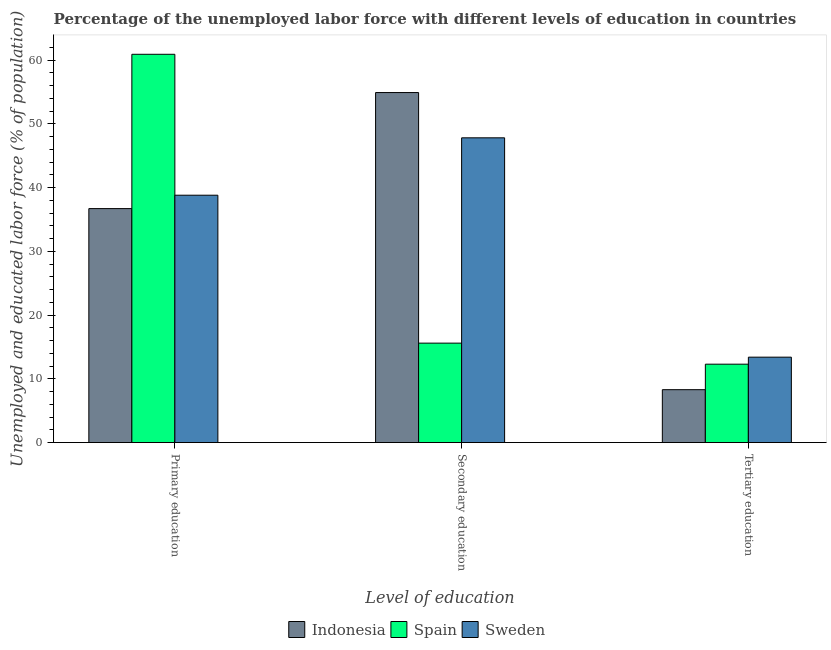How many different coloured bars are there?
Provide a short and direct response. 3. How many groups of bars are there?
Provide a succinct answer. 3. Are the number of bars on each tick of the X-axis equal?
Your answer should be very brief. Yes. What is the label of the 3rd group of bars from the left?
Keep it short and to the point. Tertiary education. What is the percentage of labor force who received tertiary education in Spain?
Ensure brevity in your answer.  12.3. Across all countries, what is the maximum percentage of labor force who received primary education?
Your answer should be very brief. 60.9. Across all countries, what is the minimum percentage of labor force who received primary education?
Keep it short and to the point. 36.7. In which country was the percentage of labor force who received tertiary education minimum?
Provide a succinct answer. Indonesia. What is the total percentage of labor force who received secondary education in the graph?
Keep it short and to the point. 118.3. What is the difference between the percentage of labor force who received primary education in Sweden and that in Spain?
Offer a very short reply. -22.1. What is the difference between the percentage of labor force who received tertiary education in Spain and the percentage of labor force who received primary education in Sweden?
Give a very brief answer. -26.5. What is the average percentage of labor force who received tertiary education per country?
Your answer should be compact. 11.33. What is the difference between the percentage of labor force who received tertiary education and percentage of labor force who received secondary education in Spain?
Your answer should be compact. -3.3. In how many countries, is the percentage of labor force who received primary education greater than 10 %?
Offer a terse response. 3. What is the ratio of the percentage of labor force who received primary education in Spain to that in Indonesia?
Provide a short and direct response. 1.66. Is the percentage of labor force who received primary education in Indonesia less than that in Spain?
Your answer should be compact. Yes. Is the difference between the percentage of labor force who received secondary education in Spain and Sweden greater than the difference between the percentage of labor force who received primary education in Spain and Sweden?
Your answer should be compact. No. What is the difference between the highest and the second highest percentage of labor force who received primary education?
Keep it short and to the point. 22.1. What is the difference between the highest and the lowest percentage of labor force who received primary education?
Give a very brief answer. 24.2. What does the 3rd bar from the left in Primary education represents?
Your answer should be compact. Sweden. What does the 3rd bar from the right in Tertiary education represents?
Give a very brief answer. Indonesia. Is it the case that in every country, the sum of the percentage of labor force who received primary education and percentage of labor force who received secondary education is greater than the percentage of labor force who received tertiary education?
Provide a succinct answer. Yes. Are all the bars in the graph horizontal?
Your answer should be very brief. No. What is the difference between two consecutive major ticks on the Y-axis?
Your answer should be very brief. 10. Are the values on the major ticks of Y-axis written in scientific E-notation?
Give a very brief answer. No. Where does the legend appear in the graph?
Provide a short and direct response. Bottom center. How many legend labels are there?
Offer a terse response. 3. How are the legend labels stacked?
Offer a terse response. Horizontal. What is the title of the graph?
Your answer should be very brief. Percentage of the unemployed labor force with different levels of education in countries. Does "Serbia" appear as one of the legend labels in the graph?
Offer a very short reply. No. What is the label or title of the X-axis?
Your answer should be compact. Level of education. What is the label or title of the Y-axis?
Your response must be concise. Unemployed and educated labor force (% of population). What is the Unemployed and educated labor force (% of population) of Indonesia in Primary education?
Your answer should be very brief. 36.7. What is the Unemployed and educated labor force (% of population) in Spain in Primary education?
Your response must be concise. 60.9. What is the Unemployed and educated labor force (% of population) of Sweden in Primary education?
Give a very brief answer. 38.8. What is the Unemployed and educated labor force (% of population) in Indonesia in Secondary education?
Your answer should be very brief. 54.9. What is the Unemployed and educated labor force (% of population) of Spain in Secondary education?
Provide a succinct answer. 15.6. What is the Unemployed and educated labor force (% of population) in Sweden in Secondary education?
Offer a terse response. 47.8. What is the Unemployed and educated labor force (% of population) in Indonesia in Tertiary education?
Offer a terse response. 8.3. What is the Unemployed and educated labor force (% of population) in Spain in Tertiary education?
Make the answer very short. 12.3. What is the Unemployed and educated labor force (% of population) in Sweden in Tertiary education?
Offer a terse response. 13.4. Across all Level of education, what is the maximum Unemployed and educated labor force (% of population) in Indonesia?
Ensure brevity in your answer.  54.9. Across all Level of education, what is the maximum Unemployed and educated labor force (% of population) in Spain?
Your response must be concise. 60.9. Across all Level of education, what is the maximum Unemployed and educated labor force (% of population) of Sweden?
Your response must be concise. 47.8. Across all Level of education, what is the minimum Unemployed and educated labor force (% of population) of Indonesia?
Ensure brevity in your answer.  8.3. Across all Level of education, what is the minimum Unemployed and educated labor force (% of population) of Spain?
Provide a succinct answer. 12.3. Across all Level of education, what is the minimum Unemployed and educated labor force (% of population) in Sweden?
Your answer should be compact. 13.4. What is the total Unemployed and educated labor force (% of population) of Indonesia in the graph?
Offer a very short reply. 99.9. What is the total Unemployed and educated labor force (% of population) of Spain in the graph?
Ensure brevity in your answer.  88.8. What is the difference between the Unemployed and educated labor force (% of population) in Indonesia in Primary education and that in Secondary education?
Make the answer very short. -18.2. What is the difference between the Unemployed and educated labor force (% of population) of Spain in Primary education and that in Secondary education?
Offer a very short reply. 45.3. What is the difference between the Unemployed and educated labor force (% of population) in Sweden in Primary education and that in Secondary education?
Make the answer very short. -9. What is the difference between the Unemployed and educated labor force (% of population) of Indonesia in Primary education and that in Tertiary education?
Give a very brief answer. 28.4. What is the difference between the Unemployed and educated labor force (% of population) of Spain in Primary education and that in Tertiary education?
Keep it short and to the point. 48.6. What is the difference between the Unemployed and educated labor force (% of population) of Sweden in Primary education and that in Tertiary education?
Ensure brevity in your answer.  25.4. What is the difference between the Unemployed and educated labor force (% of population) of Indonesia in Secondary education and that in Tertiary education?
Keep it short and to the point. 46.6. What is the difference between the Unemployed and educated labor force (% of population) of Spain in Secondary education and that in Tertiary education?
Offer a terse response. 3.3. What is the difference between the Unemployed and educated labor force (% of population) in Sweden in Secondary education and that in Tertiary education?
Provide a succinct answer. 34.4. What is the difference between the Unemployed and educated labor force (% of population) of Indonesia in Primary education and the Unemployed and educated labor force (% of population) of Spain in Secondary education?
Provide a short and direct response. 21.1. What is the difference between the Unemployed and educated labor force (% of population) of Indonesia in Primary education and the Unemployed and educated labor force (% of population) of Sweden in Secondary education?
Your answer should be very brief. -11.1. What is the difference between the Unemployed and educated labor force (% of population) in Spain in Primary education and the Unemployed and educated labor force (% of population) in Sweden in Secondary education?
Your response must be concise. 13.1. What is the difference between the Unemployed and educated labor force (% of population) in Indonesia in Primary education and the Unemployed and educated labor force (% of population) in Spain in Tertiary education?
Offer a terse response. 24.4. What is the difference between the Unemployed and educated labor force (% of population) of Indonesia in Primary education and the Unemployed and educated labor force (% of population) of Sweden in Tertiary education?
Give a very brief answer. 23.3. What is the difference between the Unemployed and educated labor force (% of population) of Spain in Primary education and the Unemployed and educated labor force (% of population) of Sweden in Tertiary education?
Keep it short and to the point. 47.5. What is the difference between the Unemployed and educated labor force (% of population) of Indonesia in Secondary education and the Unemployed and educated labor force (% of population) of Spain in Tertiary education?
Your response must be concise. 42.6. What is the difference between the Unemployed and educated labor force (% of population) of Indonesia in Secondary education and the Unemployed and educated labor force (% of population) of Sweden in Tertiary education?
Provide a succinct answer. 41.5. What is the average Unemployed and educated labor force (% of population) of Indonesia per Level of education?
Offer a terse response. 33.3. What is the average Unemployed and educated labor force (% of population) of Spain per Level of education?
Your answer should be compact. 29.6. What is the average Unemployed and educated labor force (% of population) of Sweden per Level of education?
Provide a succinct answer. 33.33. What is the difference between the Unemployed and educated labor force (% of population) of Indonesia and Unemployed and educated labor force (% of population) of Spain in Primary education?
Keep it short and to the point. -24.2. What is the difference between the Unemployed and educated labor force (% of population) of Indonesia and Unemployed and educated labor force (% of population) of Sweden in Primary education?
Your answer should be compact. -2.1. What is the difference between the Unemployed and educated labor force (% of population) of Spain and Unemployed and educated labor force (% of population) of Sweden in Primary education?
Your answer should be very brief. 22.1. What is the difference between the Unemployed and educated labor force (% of population) in Indonesia and Unemployed and educated labor force (% of population) in Spain in Secondary education?
Ensure brevity in your answer.  39.3. What is the difference between the Unemployed and educated labor force (% of population) in Spain and Unemployed and educated labor force (% of population) in Sweden in Secondary education?
Keep it short and to the point. -32.2. What is the difference between the Unemployed and educated labor force (% of population) in Indonesia and Unemployed and educated labor force (% of population) in Spain in Tertiary education?
Offer a very short reply. -4. What is the difference between the Unemployed and educated labor force (% of population) of Indonesia and Unemployed and educated labor force (% of population) of Sweden in Tertiary education?
Offer a terse response. -5.1. What is the difference between the Unemployed and educated labor force (% of population) in Spain and Unemployed and educated labor force (% of population) in Sweden in Tertiary education?
Your answer should be compact. -1.1. What is the ratio of the Unemployed and educated labor force (% of population) of Indonesia in Primary education to that in Secondary education?
Your response must be concise. 0.67. What is the ratio of the Unemployed and educated labor force (% of population) in Spain in Primary education to that in Secondary education?
Offer a terse response. 3.9. What is the ratio of the Unemployed and educated labor force (% of population) in Sweden in Primary education to that in Secondary education?
Offer a very short reply. 0.81. What is the ratio of the Unemployed and educated labor force (% of population) in Indonesia in Primary education to that in Tertiary education?
Offer a terse response. 4.42. What is the ratio of the Unemployed and educated labor force (% of population) in Spain in Primary education to that in Tertiary education?
Give a very brief answer. 4.95. What is the ratio of the Unemployed and educated labor force (% of population) in Sweden in Primary education to that in Tertiary education?
Give a very brief answer. 2.9. What is the ratio of the Unemployed and educated labor force (% of population) of Indonesia in Secondary education to that in Tertiary education?
Give a very brief answer. 6.61. What is the ratio of the Unemployed and educated labor force (% of population) of Spain in Secondary education to that in Tertiary education?
Keep it short and to the point. 1.27. What is the ratio of the Unemployed and educated labor force (% of population) in Sweden in Secondary education to that in Tertiary education?
Give a very brief answer. 3.57. What is the difference between the highest and the second highest Unemployed and educated labor force (% of population) in Indonesia?
Keep it short and to the point. 18.2. What is the difference between the highest and the second highest Unemployed and educated labor force (% of population) in Spain?
Make the answer very short. 45.3. What is the difference between the highest and the second highest Unemployed and educated labor force (% of population) of Sweden?
Offer a very short reply. 9. What is the difference between the highest and the lowest Unemployed and educated labor force (% of population) in Indonesia?
Your answer should be very brief. 46.6. What is the difference between the highest and the lowest Unemployed and educated labor force (% of population) in Spain?
Offer a very short reply. 48.6. What is the difference between the highest and the lowest Unemployed and educated labor force (% of population) of Sweden?
Make the answer very short. 34.4. 